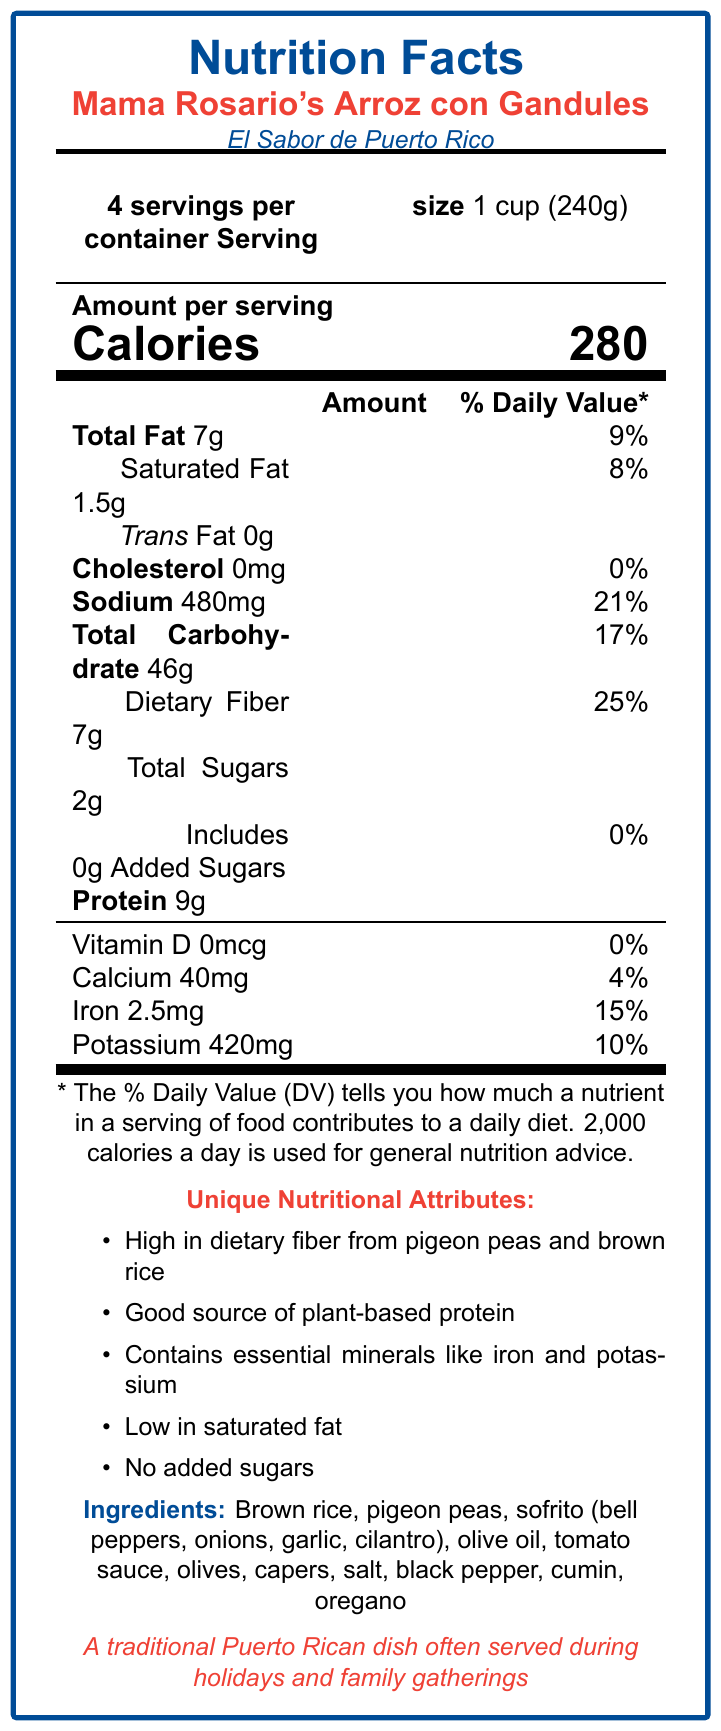what is the serving size? The serving size is listed under the subheading "Serving size" on the document, which states "1 cup (240g)".
Answer: 1 cup (240g) how many calories are there per serving? The number of calories per serving is shown under the "Amount per serving" section as 280 calories.
Answer: 280 what is the % Daily Value of sodium per serving? The % Daily Value of sodium per serving is provided in the nutrition facts section, and it is listed as 21%.
Answer: 21% what is the total carbohydrate content per serving? The total carbohydrate content per serving is shown under the "Total Carbohydrate" heading as 46g.
Answer: 46g what are the unique nutritional attributes mentioned? The unique nutritional attributes are listed in the "Unique Nutritional Attributes" section of the document.
Answer: High in dietary fiber from pigeon peas and brown rice, Good source of plant-based protein, Contains essential minerals like iron and potassium, Low in saturated fat, No added sugars which ingredient is not included in the dish? A. Tomato sauce B. Chicken C. Bell peppers D. Olives The ingredient list includes "Tomato sauce," "Bell peppers," and "Olives," but there is no mention of "Chicken."
Answer: B what is the amount of dietary fiber per serving? A. 2g B. 4g C. 7g D. 9g The nutritional facts section shows the amount of dietary fiber per serving as 7g.
Answer: C what is the % Daily Value of iron provided by this dish? A. 5% B. 10% C. 15% D. 20% The % Daily Value of iron is listed as 15%.
Answer: C is there any trans fat in this dish? The nutrition facts state "Trans Fat 0g," indicating there is no trans fat in the dish.
Answer: No does the dish contain any added sugars? The "Total Sugars" section includes a note: "Includes 0g Added Sugars," indicating there are no added sugars.
Answer: No describe the nutritional profile of Mama Rosario's Arroz con Gandules. The dish is detailed as nutritionally beneficial due to its high fiber content from pigeon peas and brown rice and being a good source of plant-based protein while being low in saturated fat and added sugars.
Answer: Mama Rosario's Arroz con Gandules is a traditional Puerto Rican dish high in dietary fiber and plant-based protein. It is low in saturated fat, contains essential minerals like iron and potassium, and includes no added sugars. Each serving is 280 calories, with significant contributions to daily values of sodium (21%) and dietary fiber (25%). what is the impact of the new stadium construction on El Sabor de Puerto Rico? The document only states that the restaurant is facing closure due to the new stadium construction, but it does not detail the specific impact or the reasons behind the displacement in depth.
Answer: Not enough information what is the main cultural significance of the dish? The cultural significance is summarized in the text describing the dish's traditional role in Puerto Rican culture.
Answer: It is a traditional Puerto Rican dish often served during holidays and family gatherings. 